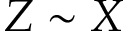Convert formula to latex. <formula><loc_0><loc_0><loc_500><loc_500>Z \sim X</formula> 